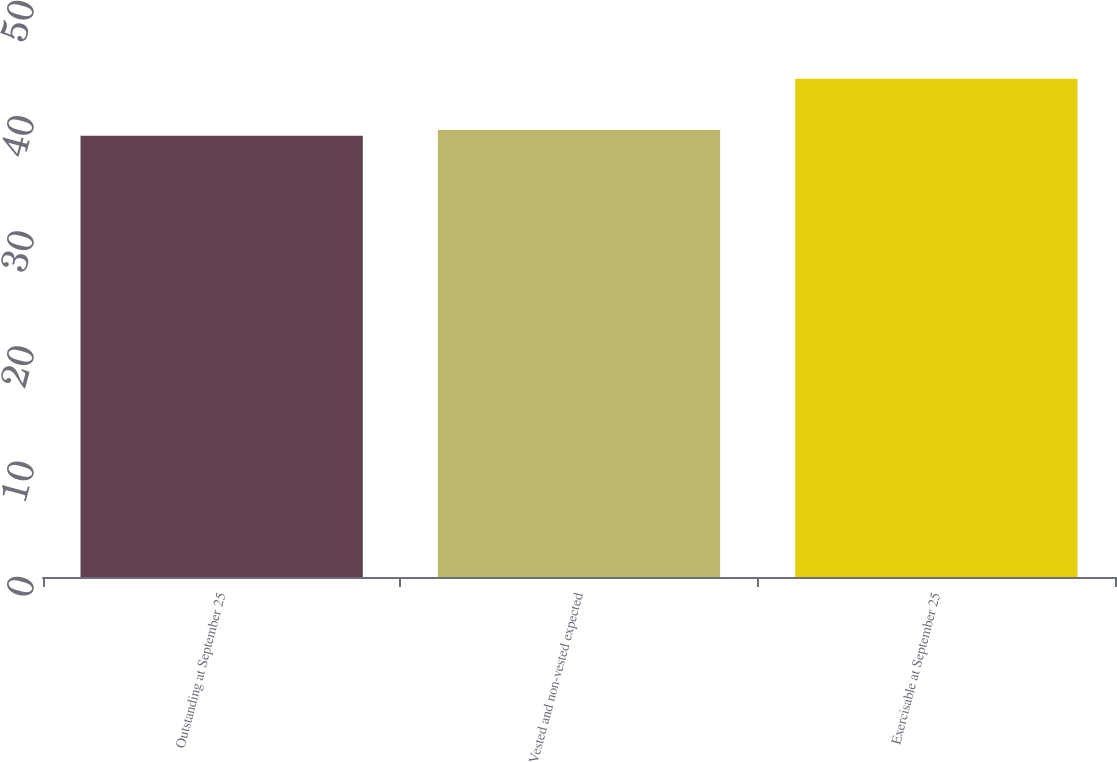<chart> <loc_0><loc_0><loc_500><loc_500><bar_chart><fcel>Outstanding at September 25<fcel>Vested and non-vested expected<fcel>Exercisable at September 25<nl><fcel>38.3<fcel>38.8<fcel>43.26<nl></chart> 